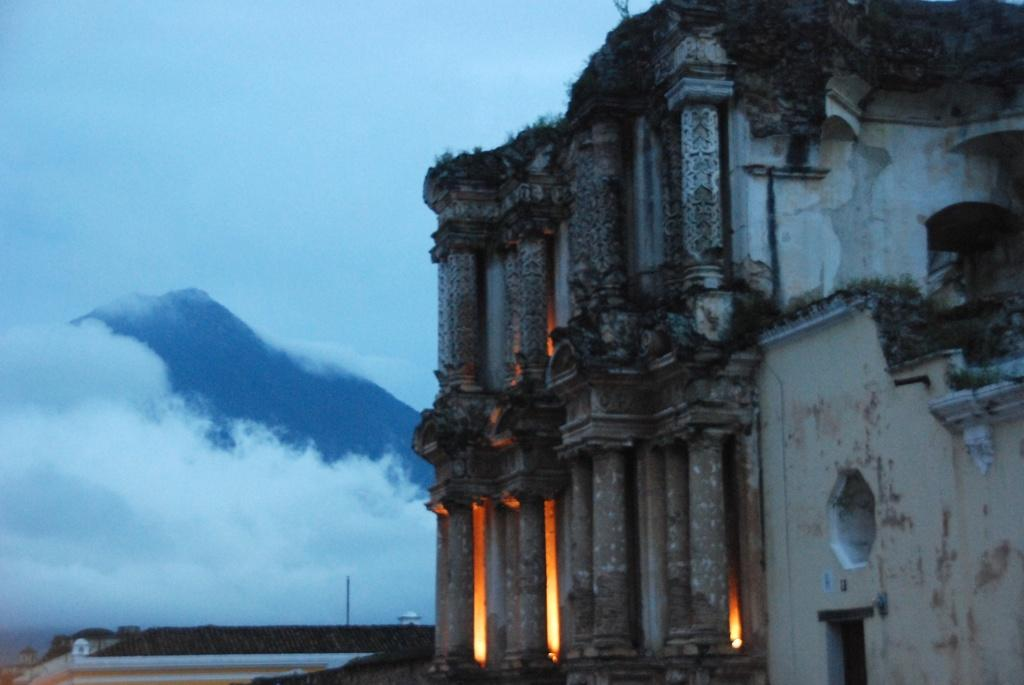What structure is the main subject of the image? There is a building in the image. What can be seen in the background of the image? There is a hill and clouds in the background of the image. What part of the natural environment is visible in the image? The sky is visible in the background of the image. What type of weather can be seen in the image? The image does not provide information about the weather; it only shows a building, a hill, clouds, and the sky. Can you tell me how many people are swimming in the image? There are no people swimming in the image. 